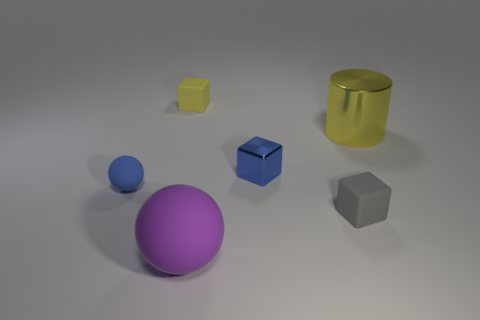What materials appear to be used for the objects in this image? The objects in the image seem to be rendered with different materials. The yellow cylinder and the purple sphere have a metallic finish, indicating they could be made of some type of metal or have a metallic coating. The blue sphere and the gray cube appear to have a matte finish, possibly suggesting a plastic or rubber material. The small yellow cube has a slightly reflective surface, which may also suggest a polished metal or hard plastic. 